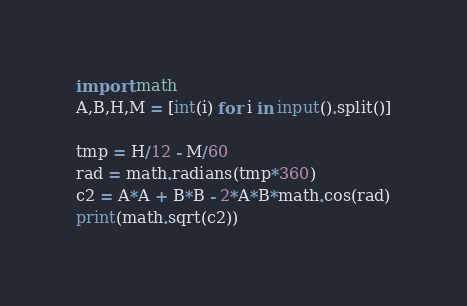<code> <loc_0><loc_0><loc_500><loc_500><_Python_>import math
A,B,H,M = [int(i) for i in input().split()]

tmp = H/12 - M/60
rad = math.radians(tmp*360)
c2 = A*A + B*B - 2*A*B*math.cos(rad)
print(math.sqrt(c2))
</code> 